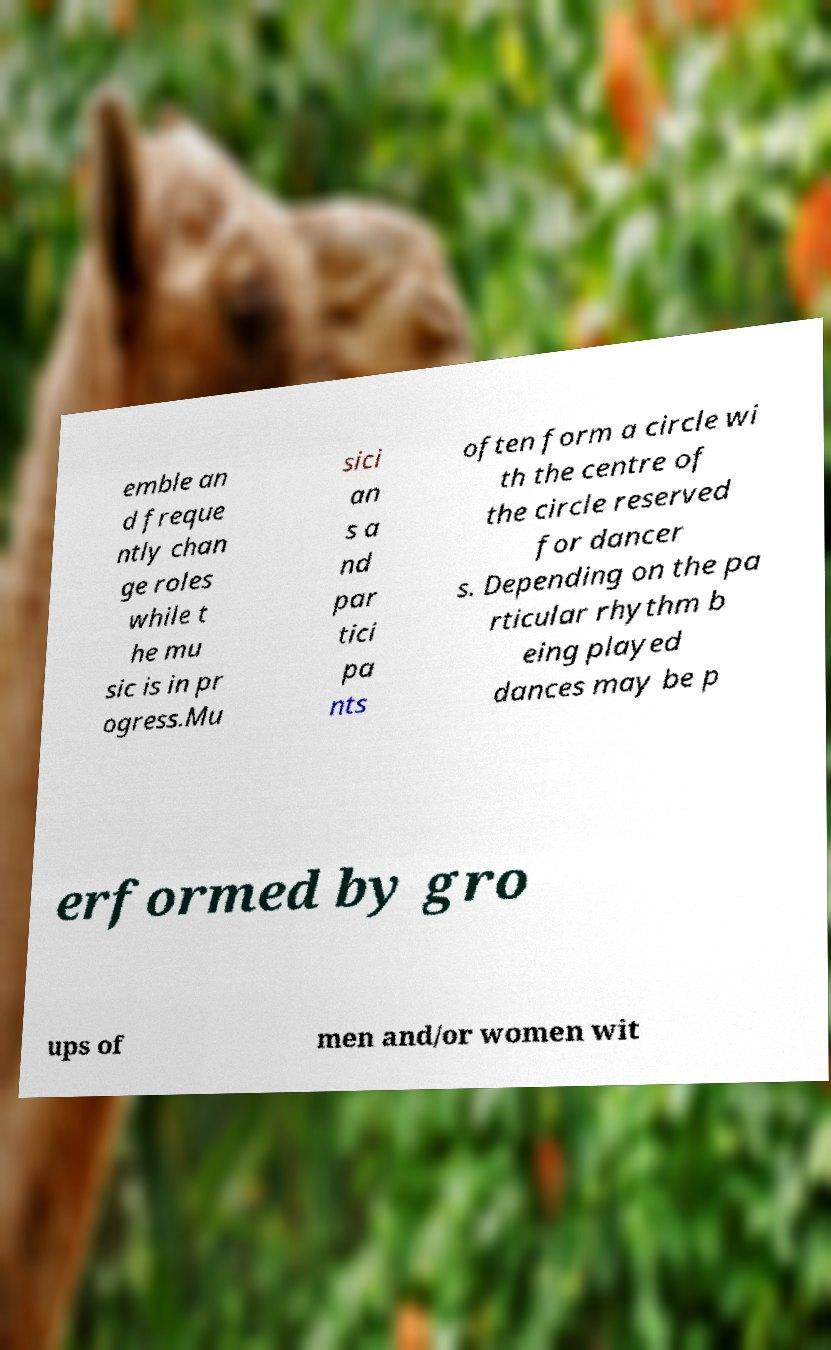Can you read and provide the text displayed in the image?This photo seems to have some interesting text. Can you extract and type it out for me? emble an d freque ntly chan ge roles while t he mu sic is in pr ogress.Mu sici an s a nd par tici pa nts often form a circle wi th the centre of the circle reserved for dancer s. Depending on the pa rticular rhythm b eing played dances may be p erformed by gro ups of men and/or women wit 